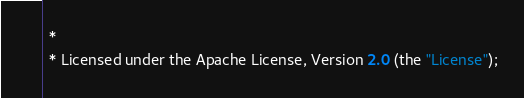Convert code to text. <code><loc_0><loc_0><loc_500><loc_500><_Scala_> *
 * Licensed under the Apache License, Version 2.0 (the "License");</code> 